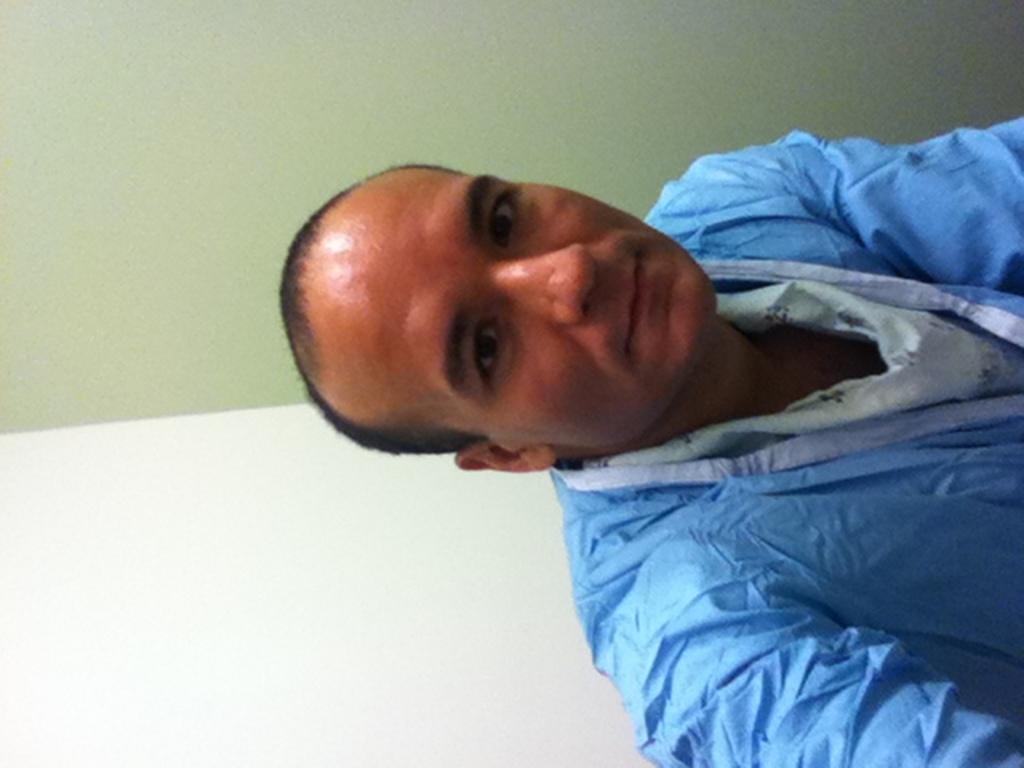Please provide a concise description of this image. In this picture we can observe a man wearing blue color dress. In the background we can observe a wall which is in white and green color. 